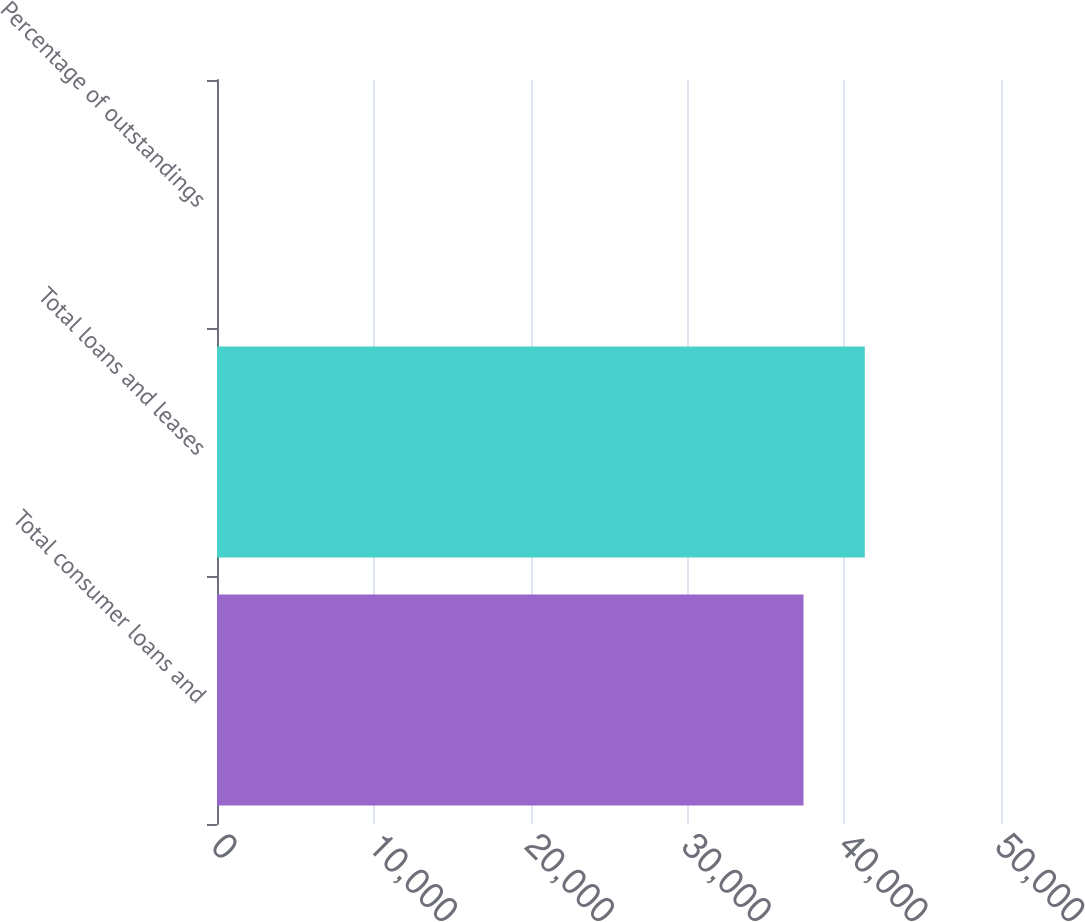<chart> <loc_0><loc_0><loc_500><loc_500><bar_chart><fcel>Total consumer loans and<fcel>Total loans and leases<fcel>Percentage of outstandings<nl><fcel>37404<fcel>41314.3<fcel>4.21<nl></chart> 